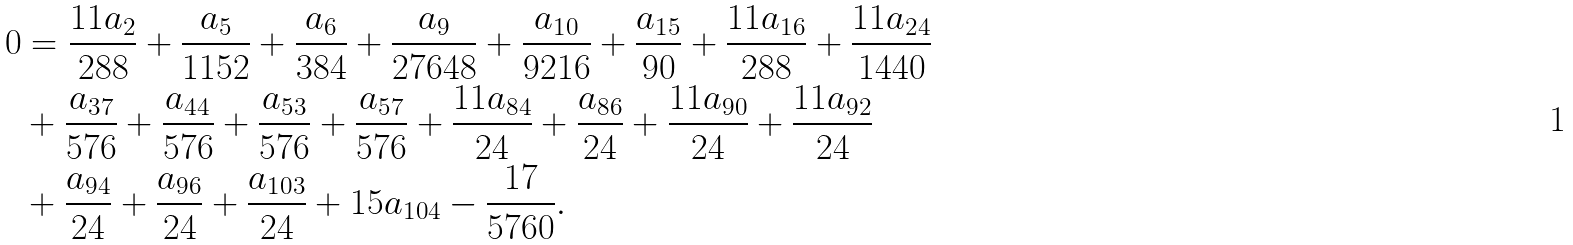Convert formula to latex. <formula><loc_0><loc_0><loc_500><loc_500>0 & = \frac { 1 1 a _ { 2 } } { 2 8 8 } + \frac { a _ { 5 } } { 1 1 5 2 } + \frac { a _ { 6 } } { 3 8 4 } + \frac { a _ { 9 } } { 2 7 6 4 8 } + \frac { a _ { 1 0 } } { 9 2 1 6 } + \frac { a _ { 1 5 } } { 9 0 } + \frac { 1 1 a _ { 1 6 } } { 2 8 8 } + \frac { 1 1 a _ { 2 4 } } { 1 4 4 0 } \\ & + \frac { a _ { 3 7 } } { 5 7 6 } + \frac { a _ { 4 4 } } { 5 7 6 } + \frac { a _ { 5 3 } } { 5 7 6 } + \frac { a _ { 5 7 } } { 5 7 6 } + \frac { 1 1 a _ { 8 4 } } { 2 4 } + \frac { a _ { 8 6 } } { 2 4 } + \frac { 1 1 a _ { 9 0 } } { 2 4 } + \frac { 1 1 a _ { 9 2 } } { 2 4 } \\ & + \frac { a _ { 9 4 } } { 2 4 } + \frac { a _ { 9 6 } } { 2 4 } + \frac { a _ { 1 0 3 } } { 2 4 } + 1 5 a _ { 1 0 4 } - \frac { 1 7 } { 5 7 6 0 } .</formula> 